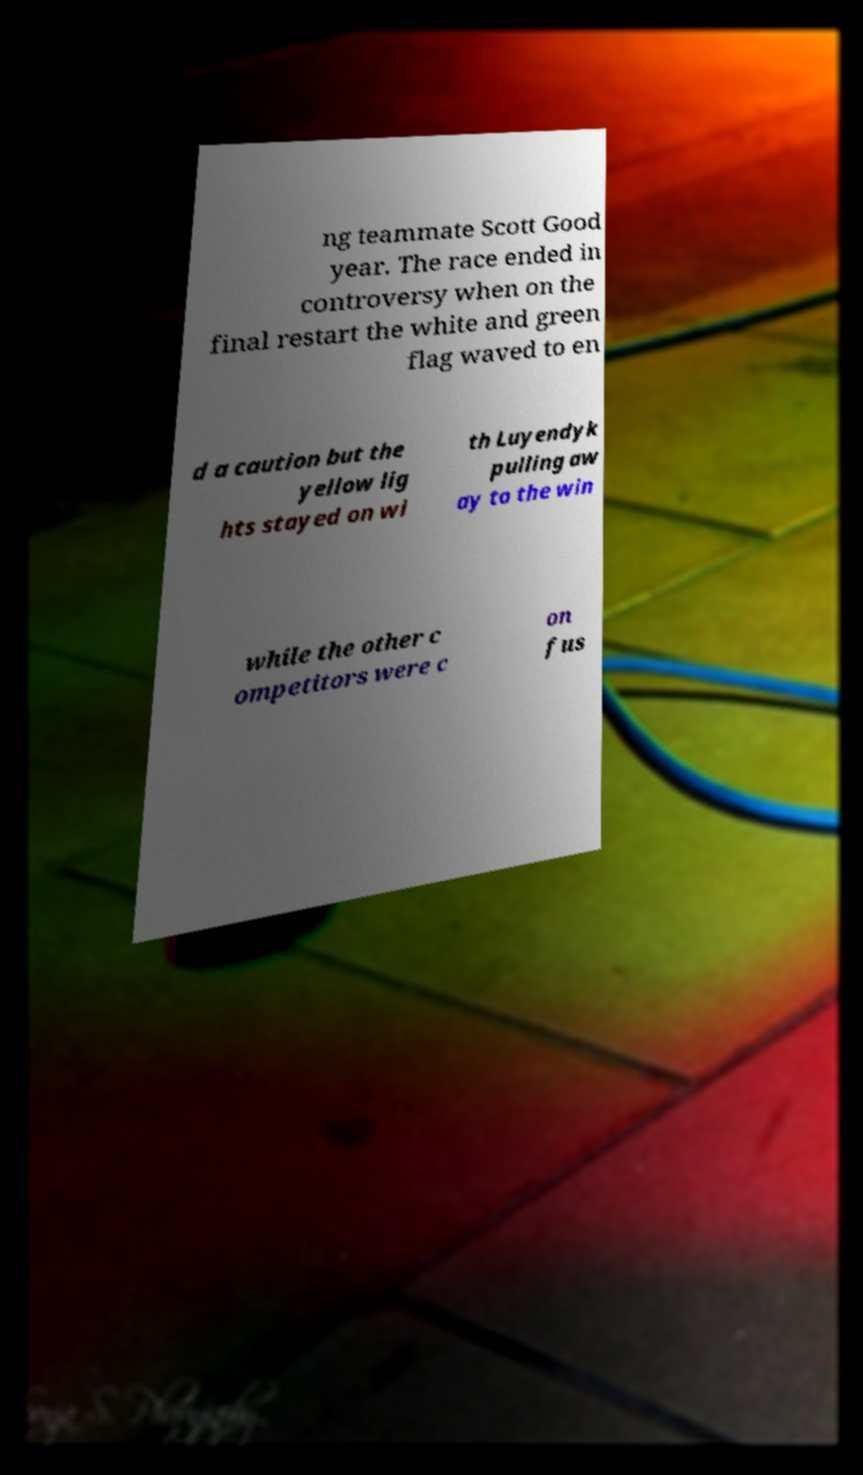Can you accurately transcribe the text from the provided image for me? ng teammate Scott Good year. The race ended in controversy when on the final restart the white and green flag waved to en d a caution but the yellow lig hts stayed on wi th Luyendyk pulling aw ay to the win while the other c ompetitors were c on fus 